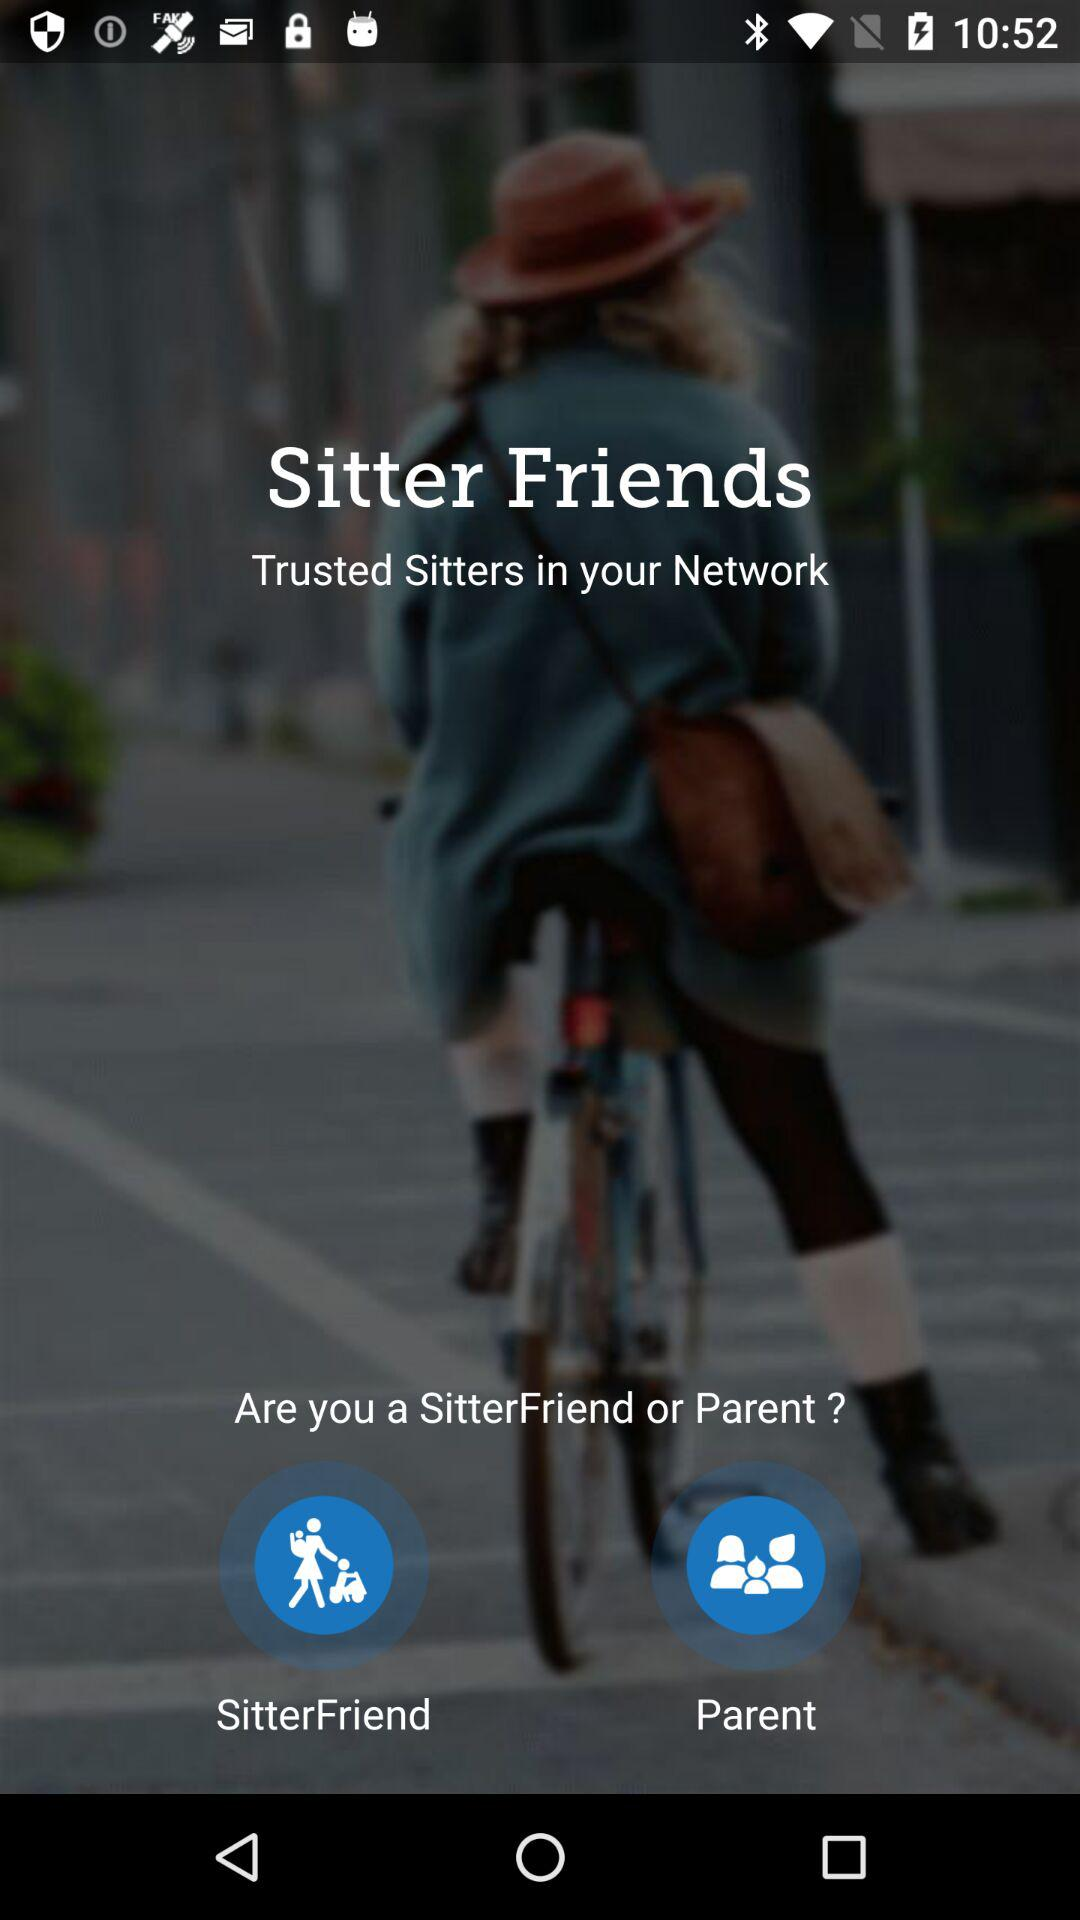What is the app name? The app name is "Sitter Friends". 